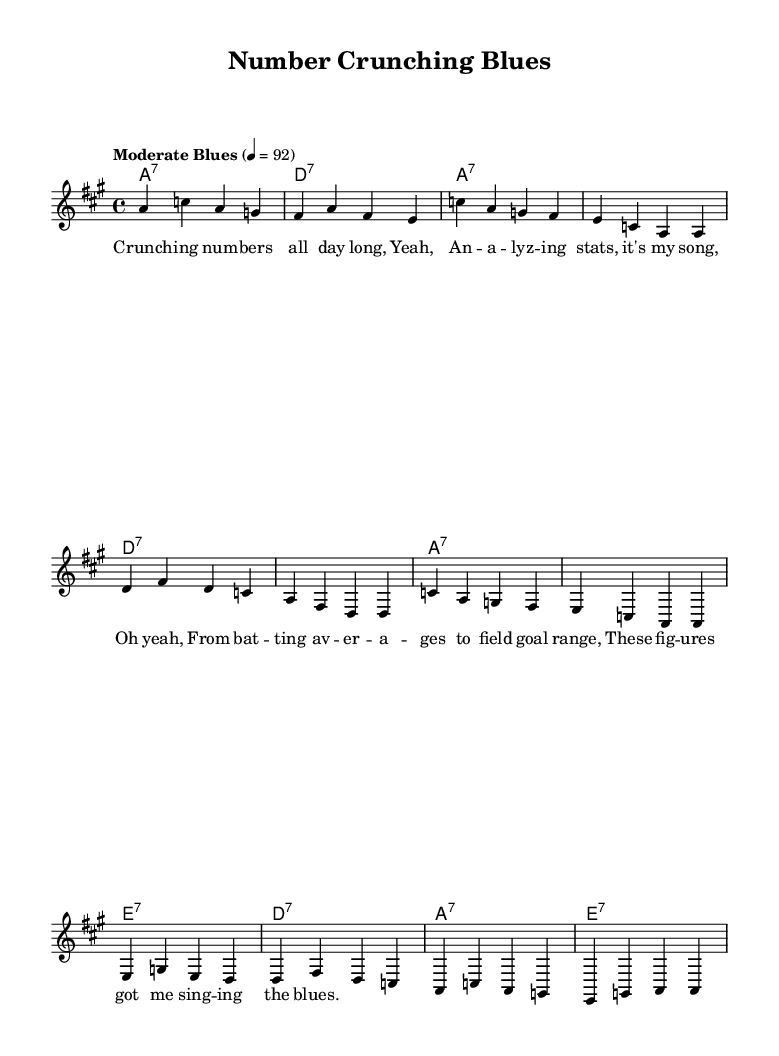What is the key signature of this music? The key signature indicates the tonal framework for the piece. In the provided music, there are three sharps, which corresponds to A major.
Answer: A major What is the time signature of the piece? The time signature is noted at the beginning of the piece, indicating how many beats are in each measure. Here, it shows 4/4, meaning there are four beats per measure, and the quarter note gets one beat.
Answer: 4/4 What is the tempo marking for the song? The tempo marking provides guidance on the speed of the piece. It is indicated as "Moderate Blues" with a metronome marking of 92 beats per minute, suggesting a moderate movement.
Answer: Moderate Blues How many measures are in the melody? By counting the distinct groups of notes or rests within the melody section, we find that there are 12 individual measures of melody.
Answer: 12 What type of chords are used in the harmony section? The harmony section uses dominant seventh chords, which are characteristic of the blues style, providing a strong tonal pull back to the root note.
Answer: Dominant seventh What is the lyrical theme of this blues song? The lyrics discuss the action of analyzing sports statistics, such as batting averages and field goal ranges, which reflects the blend of the blues genre with a statistical narrative.
Answer: Analyzing sports data How does the melody relate to the lyrics in terms of structure? The melody is structured so that it reflects the lyrical phrases, with each lyrical line corresponding to a specific musical phrase, characteristic of the call-and-response format traditionally found in blues music.
Answer: Call-and-response structure 